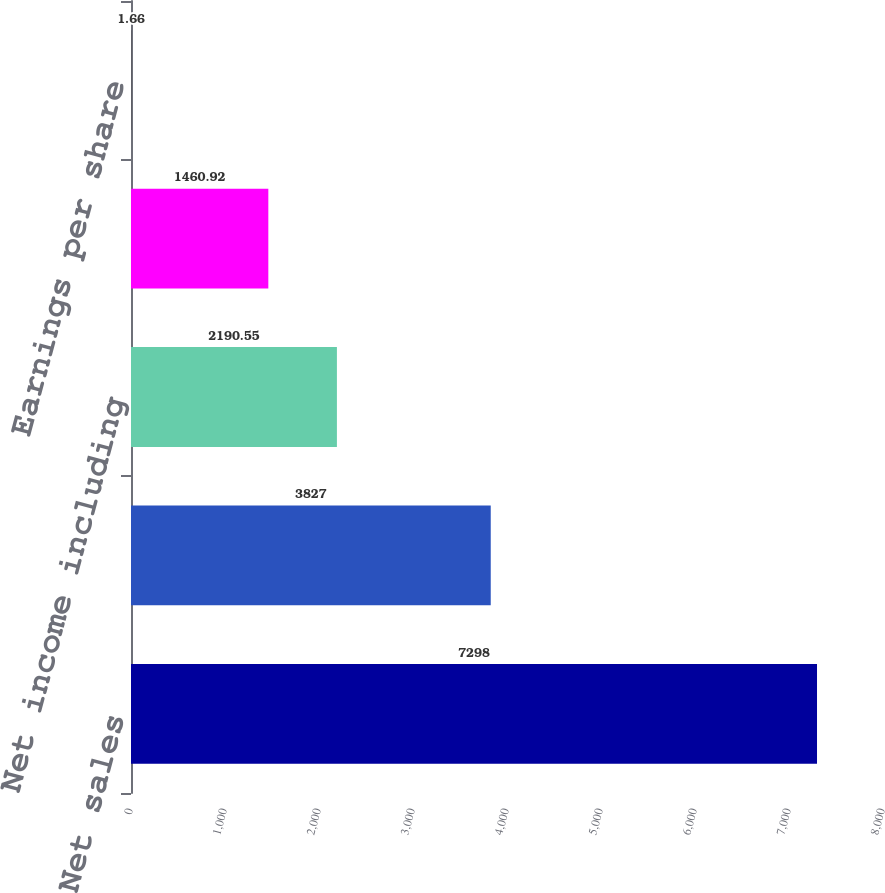<chart> <loc_0><loc_0><loc_500><loc_500><bar_chart><fcel>Net sales<fcel>Cost of sales<fcel>Net income including<fcel>Net income attributable to 3M<fcel>Earnings per share<nl><fcel>7298<fcel>3827<fcel>2190.55<fcel>1460.92<fcel>1.66<nl></chart> 